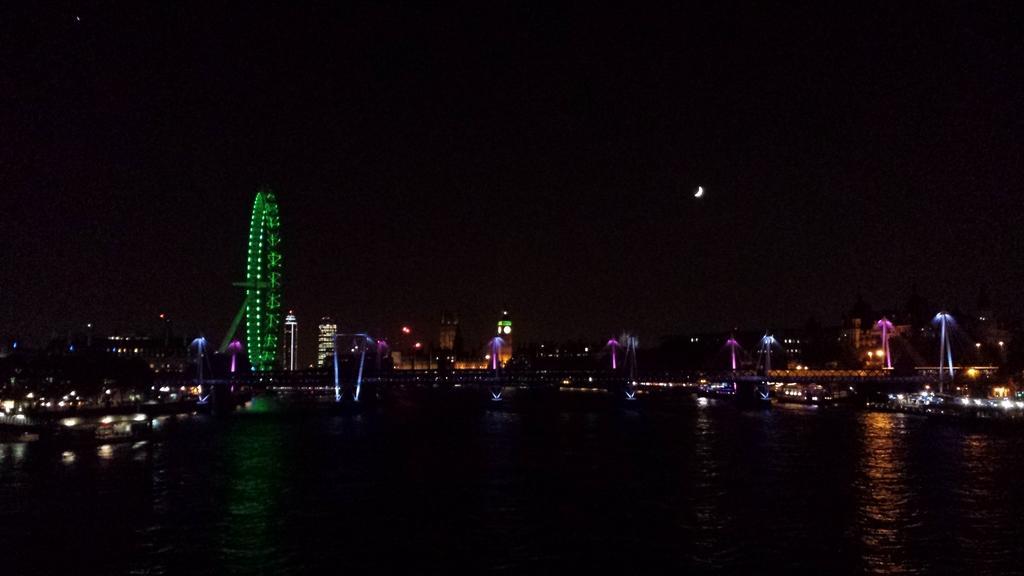Could you give a brief overview of what you see in this image? In this image, we can see a giant wheel. Buildings, lights and water. Background there is a dark. Here we can see the moon. 